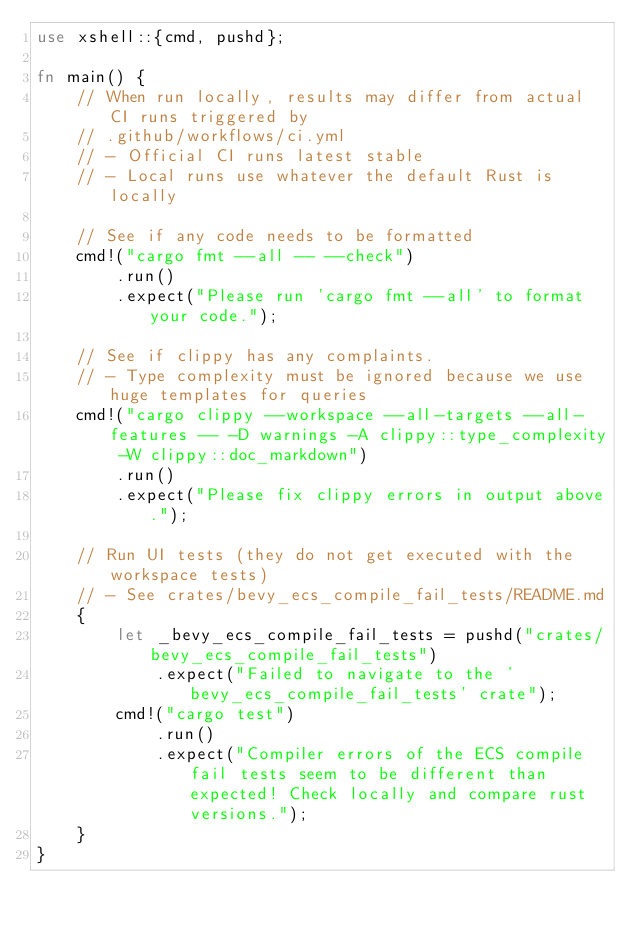<code> <loc_0><loc_0><loc_500><loc_500><_Rust_>use xshell::{cmd, pushd};

fn main() {
    // When run locally, results may differ from actual CI runs triggered by
    // .github/workflows/ci.yml
    // - Official CI runs latest stable
    // - Local runs use whatever the default Rust is locally

    // See if any code needs to be formatted
    cmd!("cargo fmt --all -- --check")
        .run()
        .expect("Please run 'cargo fmt --all' to format your code.");

    // See if clippy has any complaints.
    // - Type complexity must be ignored because we use huge templates for queries
    cmd!("cargo clippy --workspace --all-targets --all-features -- -D warnings -A clippy::type_complexity -W clippy::doc_markdown")
        .run()
        .expect("Please fix clippy errors in output above.");

    // Run UI tests (they do not get executed with the workspace tests)
    // - See crates/bevy_ecs_compile_fail_tests/README.md
    {
        let _bevy_ecs_compile_fail_tests = pushd("crates/bevy_ecs_compile_fail_tests")
            .expect("Failed to navigate to the 'bevy_ecs_compile_fail_tests' crate");
        cmd!("cargo test")
            .run()
            .expect("Compiler errors of the ECS compile fail tests seem to be different than expected! Check locally and compare rust versions.");
    }
}
</code> 